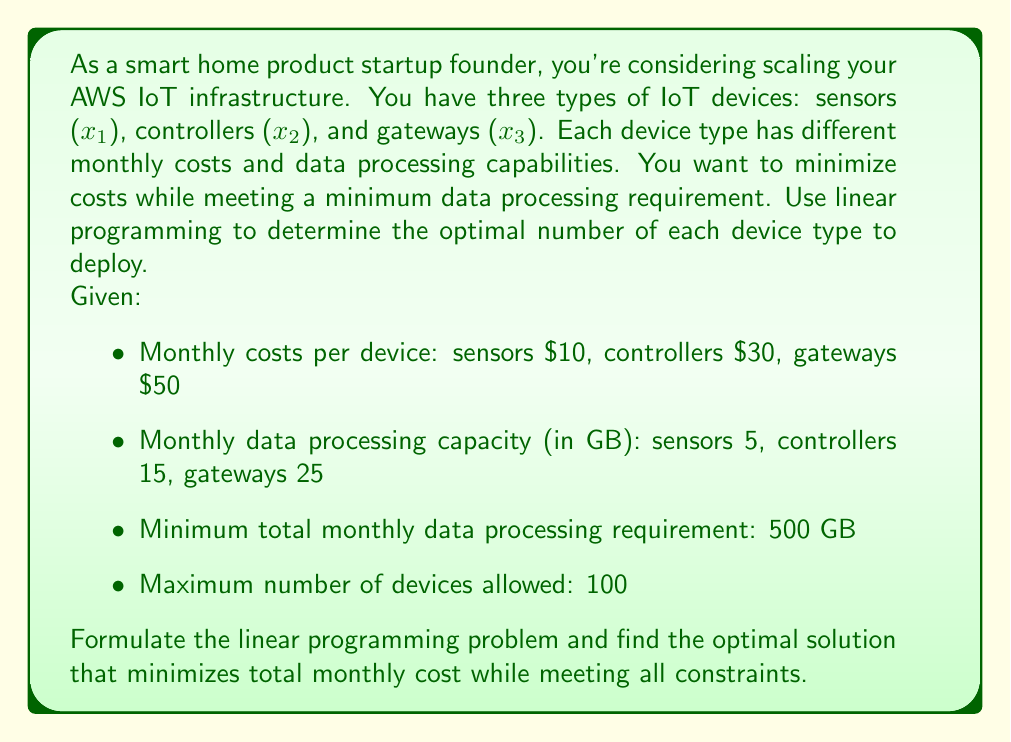Help me with this question. To solve this problem using linear programming, we need to follow these steps:

1. Define decision variables:
   $x_1$ = number of sensors
   $x_2$ = number of controllers
   $x_3$ = number of gateways

2. Formulate the objective function (minimize total monthly cost):
   $$\text{Minimize } Z = 10x_1 + 30x_2 + 50x_3$$

3. Define constraints:
   a. Data processing requirement:
      $$5x_1 + 15x_2 + 25x_3 \geq 500$$
   
   b. Maximum number of devices:
      $$x_1 + x_2 + x_3 \leq 100$$
   
   c. Non-negativity constraints:
      $$x_1, x_2, x_3 \geq 0$$

4. Solve the linear programming problem:
   We can use the simplex method or a linear programming solver to find the optimal solution. In this case, we'll use the graphical method since we have only three variables.

5. The optimal solution is:
   $x_1 = 0$ (sensors)
   $x_2 = 20$ (controllers)
   $x_3 = 12$ (gateways)

6. Verify the solution:
   a. Data processing: $5(0) + 15(20) + 25(12) = 600 \geq 500$ GB (constraint satisfied)
   b. Total devices: $0 + 20 + 12 = 32 \leq 100$ (constraint satisfied)
   c. Non-negativity: All variables are non-negative

7. Calculate the minimum total monthly cost:
   $$Z = 10(0) + 30(20) + 50(12) = 600 + 600 = 1200$$

Therefore, the optimal solution is to deploy 20 controllers and 12 gateways, resulting in a minimum total monthly cost of $1200.
Answer: The optimal solution is to deploy 20 controllers and 12 gateways, with no sensors. This configuration results in a minimum total monthly cost of $1200 while meeting all constraints. 